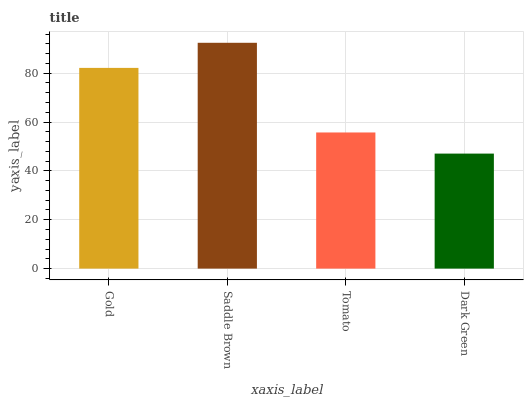Is Dark Green the minimum?
Answer yes or no. Yes. Is Saddle Brown the maximum?
Answer yes or no. Yes. Is Tomato the minimum?
Answer yes or no. No. Is Tomato the maximum?
Answer yes or no. No. Is Saddle Brown greater than Tomato?
Answer yes or no. Yes. Is Tomato less than Saddle Brown?
Answer yes or no. Yes. Is Tomato greater than Saddle Brown?
Answer yes or no. No. Is Saddle Brown less than Tomato?
Answer yes or no. No. Is Gold the high median?
Answer yes or no. Yes. Is Tomato the low median?
Answer yes or no. Yes. Is Dark Green the high median?
Answer yes or no. No. Is Saddle Brown the low median?
Answer yes or no. No. 